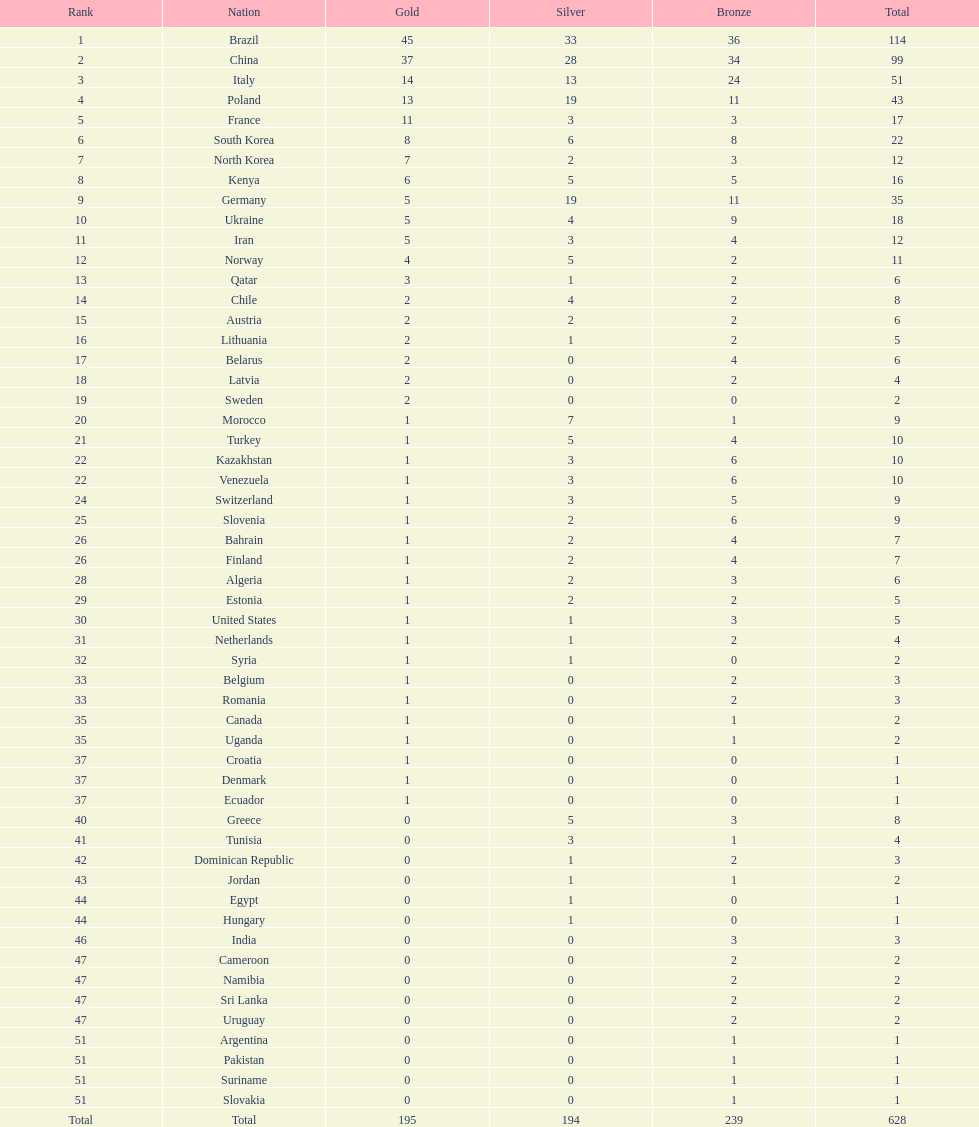Who only won 13 silver medals? Italy. 